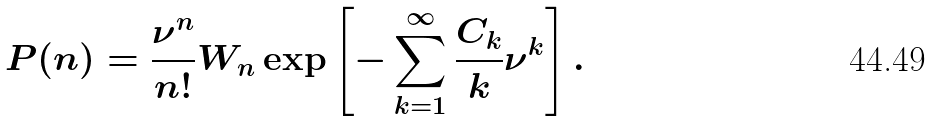Convert formula to latex. <formula><loc_0><loc_0><loc_500><loc_500>P ( n ) = \frac { \nu ^ { n } } { n ! } W _ { n } \exp \left [ - \sum _ { k = 1 } ^ { \infty } \frac { C _ { k } } { k } \nu ^ { k } \right ] .</formula> 